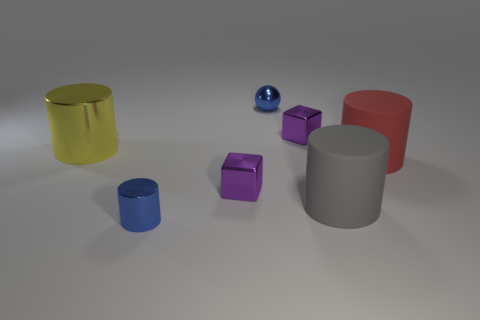How many other objects are there of the same color as the big shiny object?
Make the answer very short. 0. Is there anything else that has the same size as the gray cylinder?
Make the answer very short. Yes. Are there any gray rubber things to the left of the big yellow shiny thing?
Your answer should be compact. No. What number of large gray things have the same shape as the yellow metallic object?
Your answer should be compact. 1. There is a large cylinder that is to the left of the blue metal object behind the matte cylinder that is left of the red cylinder; what is its color?
Give a very brief answer. Yellow. Is the cube on the right side of the shiny sphere made of the same material as the big object that is to the left of the large gray object?
Offer a terse response. Yes. How many things are either large things that are behind the big red matte cylinder or small metallic blocks?
Offer a terse response. 3. What number of things are either big yellow matte spheres or blue things to the right of the tiny metal cylinder?
Ensure brevity in your answer.  1. What number of red rubber cylinders are the same size as the yellow cylinder?
Offer a very short reply. 1. Are there fewer tiny metallic spheres that are in front of the blue cylinder than purple objects behind the big yellow cylinder?
Ensure brevity in your answer.  Yes. 